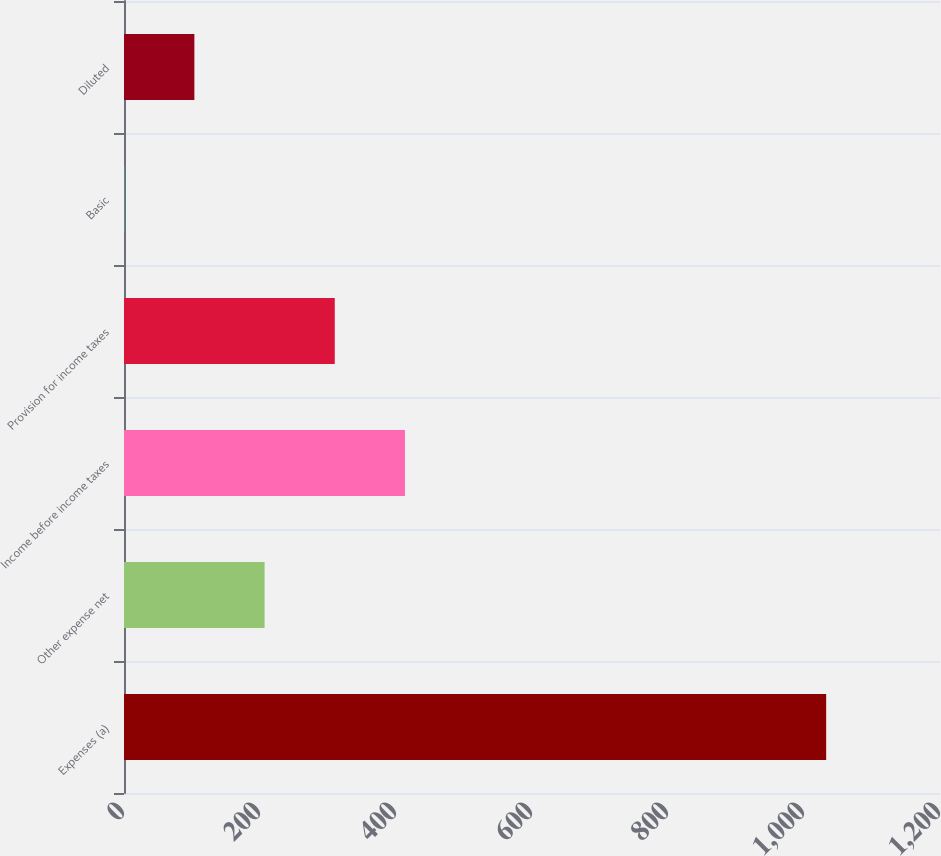<chart> <loc_0><loc_0><loc_500><loc_500><bar_chart><fcel>Expenses (a)<fcel>Other expense net<fcel>Income before income taxes<fcel>Provision for income taxes<fcel>Basic<fcel>Diluted<nl><fcel>1032.6<fcel>206.72<fcel>413.18<fcel>309.95<fcel>0.26<fcel>103.49<nl></chart> 